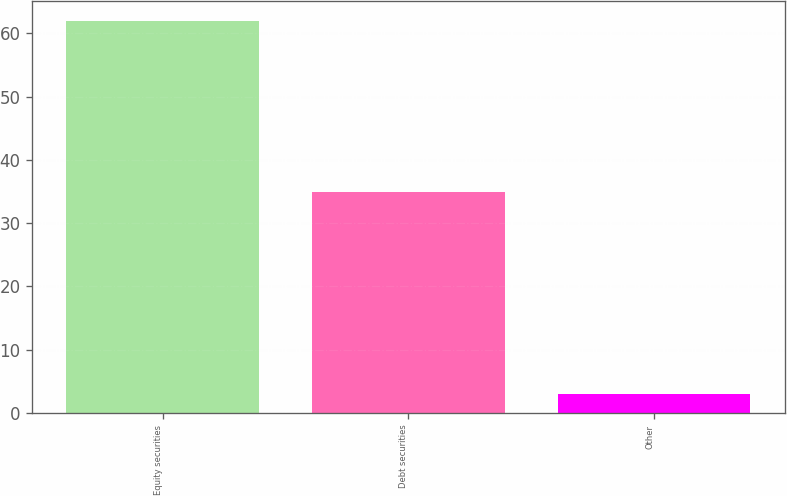<chart> <loc_0><loc_0><loc_500><loc_500><bar_chart><fcel>Equity securities<fcel>Debt securities<fcel>Other<nl><fcel>62<fcel>35<fcel>3<nl></chart> 